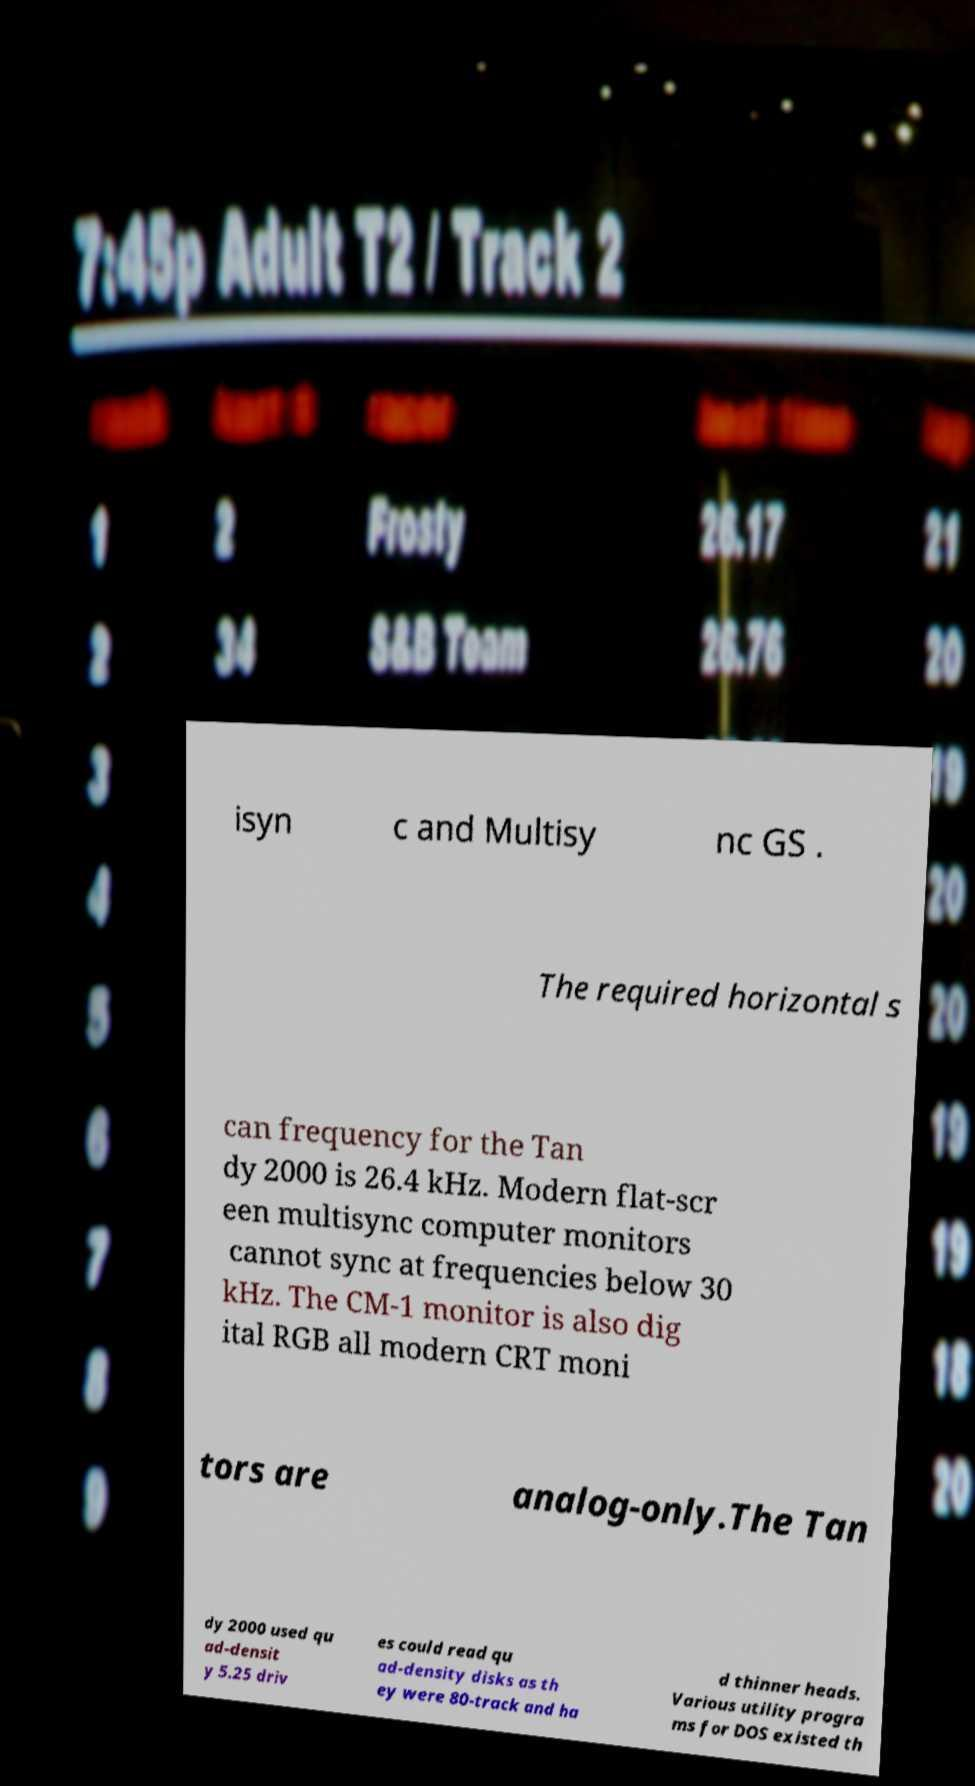Please identify and transcribe the text found in this image. isyn c and Multisy nc GS . The required horizontal s can frequency for the Tan dy 2000 is 26.4 kHz. Modern flat-scr een multisync computer monitors cannot sync at frequencies below 30 kHz. The CM-1 monitor is also dig ital RGB all modern CRT moni tors are analog-only.The Tan dy 2000 used qu ad-densit y 5.25 driv es could read qu ad-density disks as th ey were 80-track and ha d thinner heads. Various utility progra ms for DOS existed th 